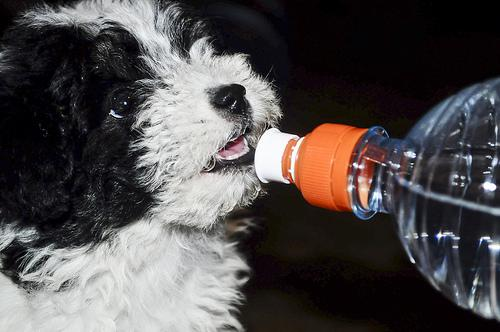Question: what is in the bottle?
Choices:
A. Wine.
B. Juice.
C. Soda.
D. It's water.
Answer with the letter. Answer: D Question: who is the dog looking at?
Choices:
A. The cat.
B. The frisbee.
C. The dog is looking at its owner.
D. The baby.
Answer with the letter. Answer: C Question: when was the picture taken?
Choices:
A. Afternoon.
B. The picture was taken in the evening.
C. Morning.
D. Midnight.
Answer with the letter. Answer: B Question: what color is the dog?
Choices:
A. The dog is brown and white.
B. The dog is brown and black.
C. The dog is yellow and brown.
D. The dog is black and white.
Answer with the letter. Answer: D 